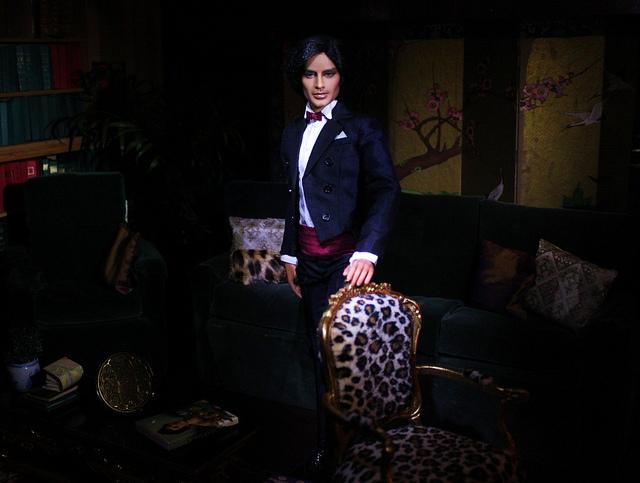Is the man a model?
Write a very short answer. Yes. Is this a man or woman?
Write a very short answer. Man. What pattern is the cloth on the chair?
Answer briefly. Leopard. Are the lights on?
Write a very short answer. No. 